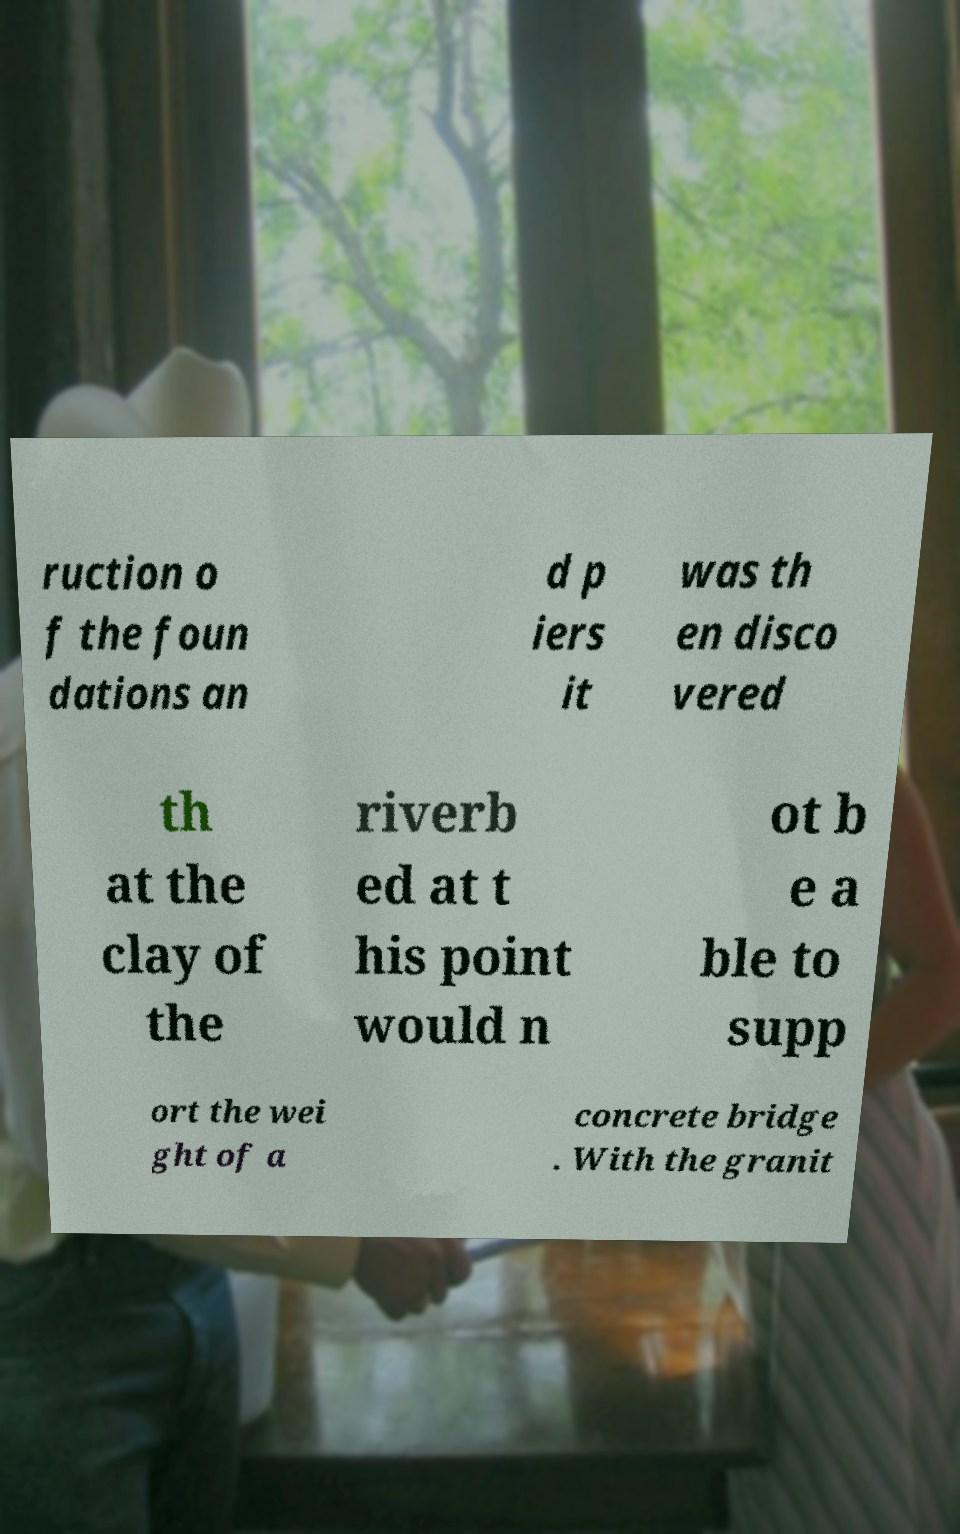There's text embedded in this image that I need extracted. Can you transcribe it verbatim? ruction o f the foun dations an d p iers it was th en disco vered th at the clay of the riverb ed at t his point would n ot b e a ble to supp ort the wei ght of a concrete bridge . With the granit 